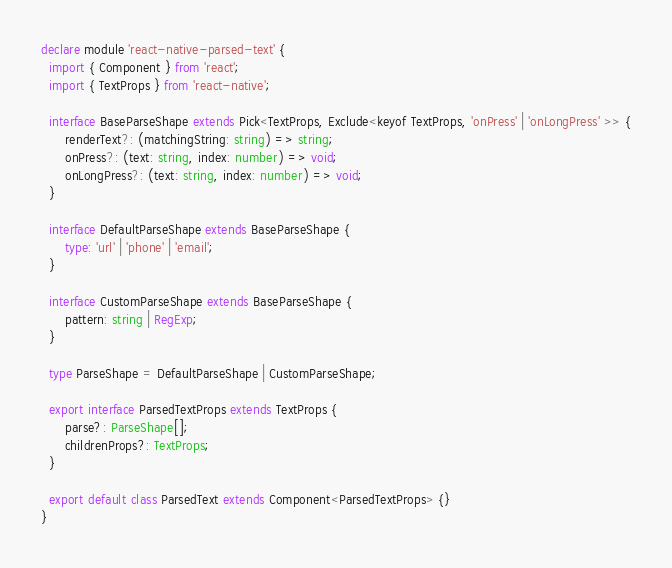Convert code to text. <code><loc_0><loc_0><loc_500><loc_500><_TypeScript_>declare module 'react-native-parsed-text' {
  import { Component } from 'react';
  import { TextProps } from 'react-native';

  interface BaseParseShape extends Pick<TextProps, Exclude<keyof TextProps, 'onPress' | 'onLongPress' >> {
      renderText?: (matchingString: string) => string;
      onPress?: (text: string, index: number) => void;
      onLongPress?: (text: string, index: number) => void;
  }

  interface DefaultParseShape extends BaseParseShape {
      type: 'url' | 'phone' | 'email';
  }

  interface CustomParseShape extends BaseParseShape {
      pattern: string | RegExp;
  }

  type ParseShape = DefaultParseShape | CustomParseShape;

  export interface ParsedTextProps extends TextProps {
      parse?: ParseShape[];
      childrenProps?: TextProps;
  }

  export default class ParsedText extends Component<ParsedTextProps> {}
}
</code> 